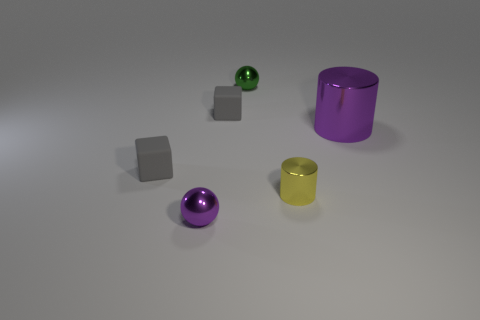Is there any other thing that is the same size as the purple cylinder?
Provide a short and direct response. No. Is the color of the sphere in front of the small yellow metallic thing the same as the metal cylinder that is on the right side of the yellow object?
Your response must be concise. Yes. Are there any small purple metallic things of the same shape as the tiny green thing?
Make the answer very short. Yes. The purple object that is the same size as the green metallic thing is what shape?
Make the answer very short. Sphere. How many tiny metal things have the same color as the large metal cylinder?
Ensure brevity in your answer.  1. There is a purple thing that is on the right side of the green object; what size is it?
Make the answer very short. Large. How many metallic cylinders are the same size as the green object?
Ensure brevity in your answer.  1. What is the color of the big thing that is made of the same material as the small green sphere?
Give a very brief answer. Purple. Are there fewer rubber blocks that are behind the purple cylinder than big purple shiny cylinders?
Make the answer very short. No. There is a small yellow thing that is made of the same material as the green object; what is its shape?
Ensure brevity in your answer.  Cylinder. 